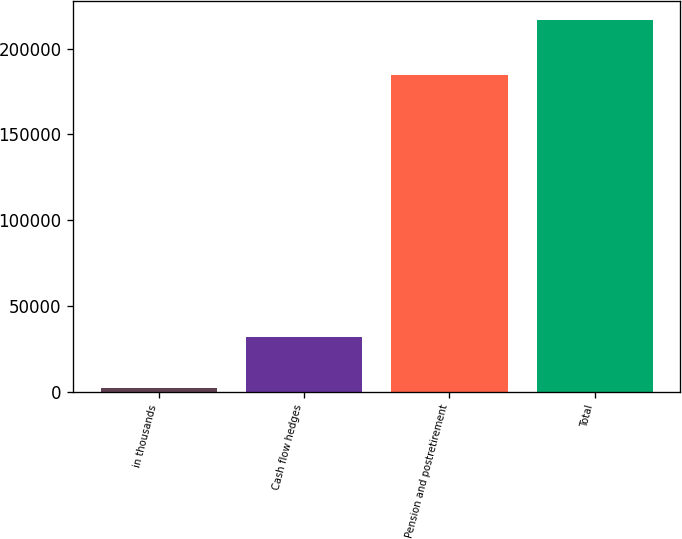Convert chart to OTSL. <chart><loc_0><loc_0><loc_500><loc_500><bar_chart><fcel>in thousands<fcel>Cash flow hedges<fcel>Pension and postretirement<fcel>Total<nl><fcel>2011<fcel>31986<fcel>184858<fcel>216844<nl></chart> 